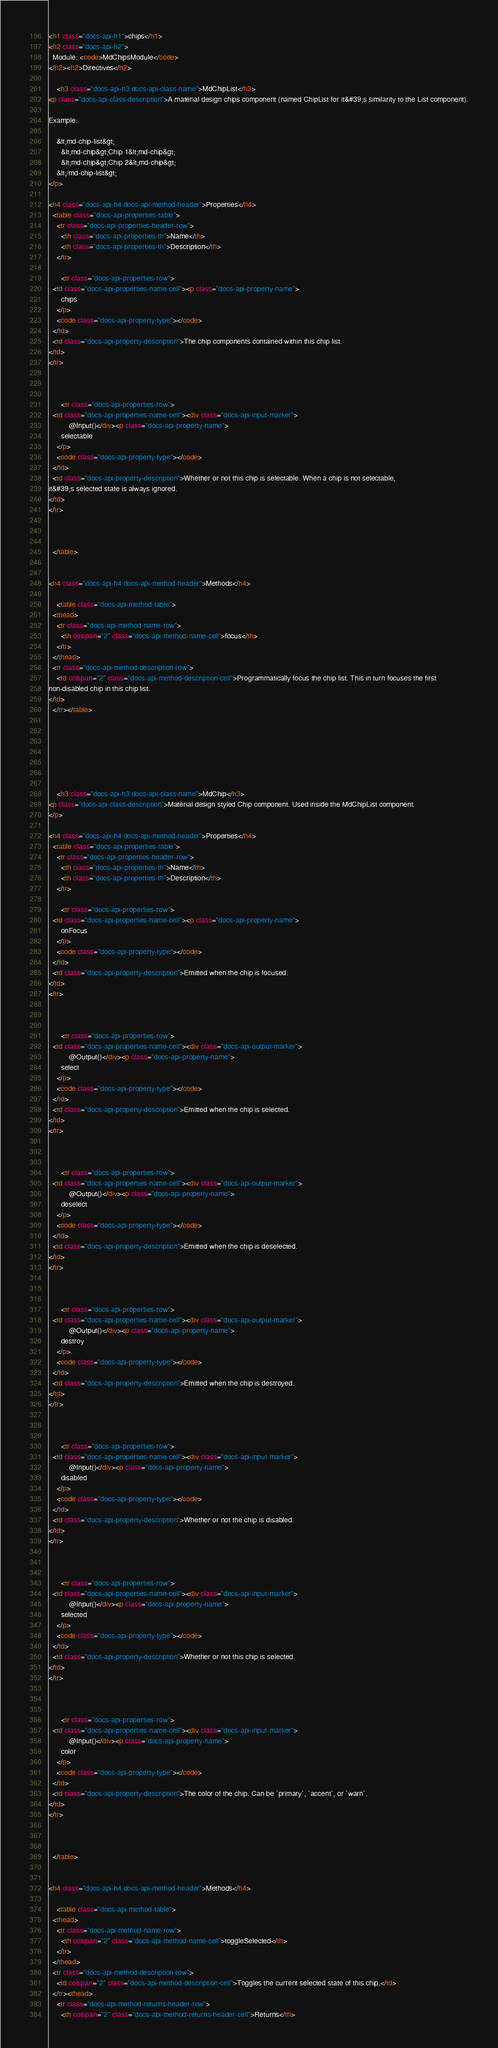Convert code to text. <code><loc_0><loc_0><loc_500><loc_500><_HTML_>










<h1 class="docs-api-h1">chips</h1>
<h2 class="docs-api-h2">
  Module: <code>MdChipsModule</code>
</h2><h2>Directives</h2>
  
    <h3 class="docs-api-h3 docs-api-class-name">MdChipList</h3>
<p class="docs-api-class-description">A material design chips component (named ChipList for it&#39;s similarity to the List component).

Example:

    &lt;md-chip-list&gt;
      &lt;md-chip&gt;Chip 1&lt;md-chip&gt;
      &lt;md-chip&gt;Chip 2&lt;md-chip&gt;
    &lt;/md-chip-list&gt;
</p>

<h4 class="docs-api-h4 docs-api-method-header">Properties</h4>
  <table class="docs-api-properties-table">
    <tr class="docs-api-properties-header-row">
      <th class="docs-api-properties-th">Name</th>
      <th class="docs-api-properties-th">Description</th>
    </tr>
    
      <tr class="docs-api-properties-row">
  <td class="docs-api-properties-name-cell"><p class="docs-api-property-name">
      chips
    </p>
    <code class="docs-api-property-type"></code>
  </td>
  <td class="docs-api-property-description">The chip components contained within this chip list.
</td>
</tr>


    
      <tr class="docs-api-properties-row">
  <td class="docs-api-properties-name-cell"><div class="docs-api-input-marker">
          @Input()</div><p class="docs-api-property-name">
      selectable
    </p>
    <code class="docs-api-property-type"></code>
  </td>
  <td class="docs-api-property-description">Whether or not this chip is selectable. When a chip is not selectable,
it&#39;s selected state is always ignored.
</td>
</tr>


    
  </table>


<h4 class="docs-api-h4 docs-api-method-header">Methods</h4>
  
    <table class="docs-api-method-table">
  <thead>
    <tr class="docs-api-method-name-row">
      <th colspan="2" class="docs-api-method-name-cell">focus</th>
    </tr>
  </thead>
  <tr class="docs-api-method-description-row">
    <td colspan="2" class="docs-api-method-description-cell">Programmatically focus the chip list. This in turn focuses the first
non-disabled chip in this chip list.
</td>
  </tr></table>


  



  
    <h3 class="docs-api-h3 docs-api-class-name">MdChip</h3>
<p class="docs-api-class-description">Material design styled Chip component. Used inside the MdChipList component.
</p>

<h4 class="docs-api-h4 docs-api-method-header">Properties</h4>
  <table class="docs-api-properties-table">
    <tr class="docs-api-properties-header-row">
      <th class="docs-api-properties-th">Name</th>
      <th class="docs-api-properties-th">Description</th>
    </tr>
    
      <tr class="docs-api-properties-row">
  <td class="docs-api-properties-name-cell"><p class="docs-api-property-name">
      onFocus
    </p>
    <code class="docs-api-property-type"></code>
  </td>
  <td class="docs-api-property-description">Emitted when the chip is focused.
</td>
</tr>


    
      <tr class="docs-api-properties-row">
  <td class="docs-api-properties-name-cell"><div class="docs-api-output-marker">
          @Output()</div><p class="docs-api-property-name">
      select
    </p>
    <code class="docs-api-property-type"></code>
  </td>
  <td class="docs-api-property-description">Emitted when the chip is selected.
</td>
</tr>


    
      <tr class="docs-api-properties-row">
  <td class="docs-api-properties-name-cell"><div class="docs-api-output-marker">
          @Output()</div><p class="docs-api-property-name">
      deselect
    </p>
    <code class="docs-api-property-type"></code>
  </td>
  <td class="docs-api-property-description">Emitted when the chip is deselected.
</td>
</tr>


    
      <tr class="docs-api-properties-row">
  <td class="docs-api-properties-name-cell"><div class="docs-api-output-marker">
          @Output()</div><p class="docs-api-property-name">
      destroy
    </p>
    <code class="docs-api-property-type"></code>
  </td>
  <td class="docs-api-property-description">Emitted when the chip is destroyed.
</td>
</tr>


    
      <tr class="docs-api-properties-row">
  <td class="docs-api-properties-name-cell"><div class="docs-api-input-marker">
          @Input()</div><p class="docs-api-property-name">
      disabled
    </p>
    <code class="docs-api-property-type"></code>
  </td>
  <td class="docs-api-property-description">Whether or not the chip is disabled.
</td>
</tr>


    
      <tr class="docs-api-properties-row">
  <td class="docs-api-properties-name-cell"><div class="docs-api-input-marker">
          @Input()</div><p class="docs-api-property-name">
      selected
    </p>
    <code class="docs-api-property-type"></code>
  </td>
  <td class="docs-api-property-description">Whether or not this chip is selected.
</td>
</tr>


    
      <tr class="docs-api-properties-row">
  <td class="docs-api-properties-name-cell"><div class="docs-api-input-marker">
          @Input()</div><p class="docs-api-property-name">
      color
    </p>
    <code class="docs-api-property-type"></code>
  </td>
  <td class="docs-api-property-description">The color of the chip. Can be `primary`, `accent`, or `warn`.
</td>
</tr>


    
  </table>


<h4 class="docs-api-h4 docs-api-method-header">Methods</h4>
  
    <table class="docs-api-method-table">
  <thead>
    <tr class="docs-api-method-name-row">
      <th colspan="2" class="docs-api-method-name-cell">toggleSelected</th>
    </tr>
  </thead>
  <tr class="docs-api-method-description-row">
    <td colspan="2" class="docs-api-method-description-cell">Toggles the current selected state of this chip.</td>
  </tr><thead>
    <tr class="docs-api-method-returns-header-row">
      <th colspan="2" class="docs-api-method-returns-header-cell">Returns</th></code> 